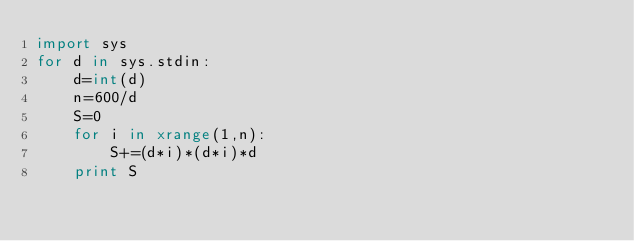<code> <loc_0><loc_0><loc_500><loc_500><_Python_>import sys
for d in sys.stdin:
    d=int(d)
    n=600/d
    S=0
    for i in xrange(1,n):
        S+=(d*i)*(d*i)*d
    print S</code> 